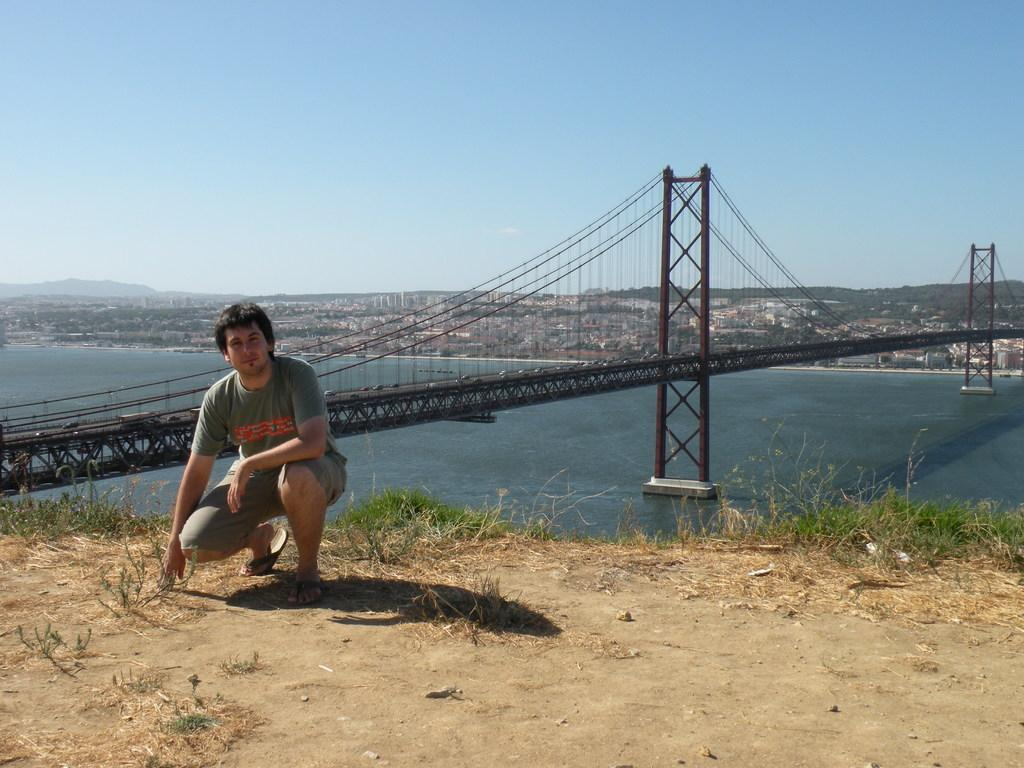Who is present in the image? There is a man in the image. What structure can be seen in the image? There is a bridge in the image. What natural element is visible in the image? There is water visible in the image. What type of man-made structures can be seen in the image? There are buildings in the image. What type of vegetation is present in the image? There are trees in the image. What is visible in the background of the image? The sky is visible in the background of the image. What type of basket is the writer using to solve arithmetic problems in the image? There is no basket, writer, or arithmetic problems present in the image. 